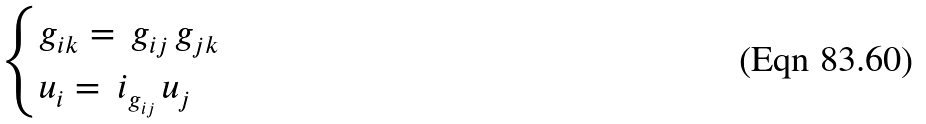Convert formula to latex. <formula><loc_0><loc_0><loc_500><loc_500>\begin{cases} g _ { i k } = \, g _ { i j } \, g _ { j k } \\ u _ { i } = \, i _ { g _ { i j } } \, u _ { j } \end{cases}</formula> 